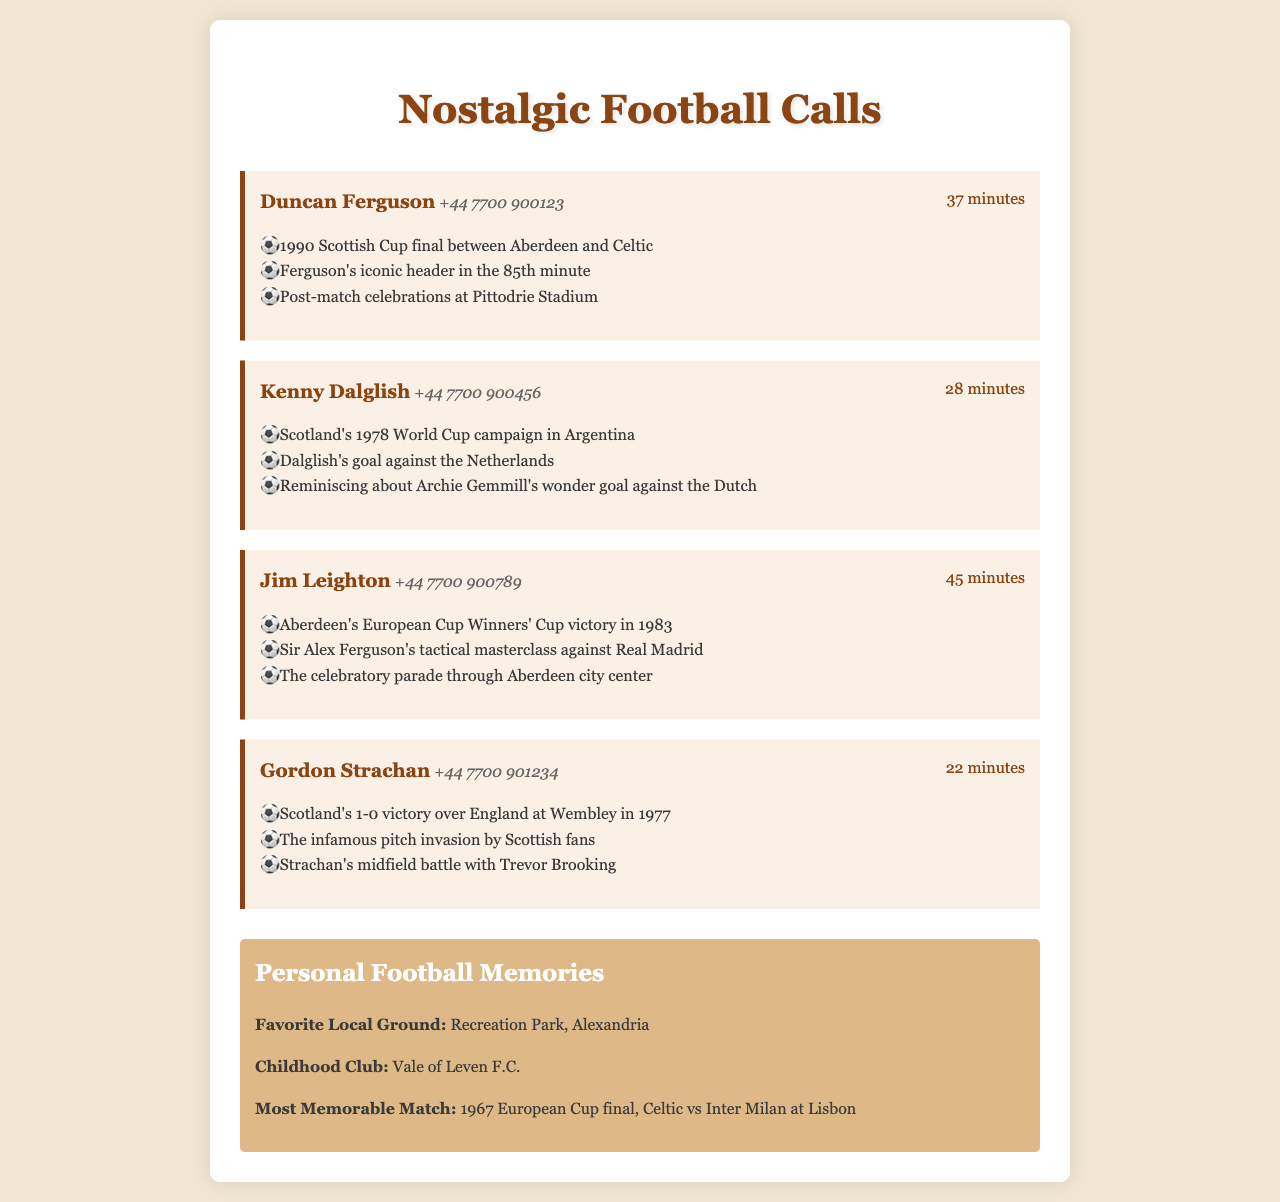What is the name of the first caller? The name of the first caller is provided in the document as Duncan Ferguson.
Answer: Duncan Ferguson How long was the call with Jim Leighton? The duration of the call with Jim Leighton is specified in the document as 45 minutes.
Answer: 45 minutes What significant football event did Gordon Strachan discuss? The document lists Scotland's 1-0 victory over England at Wembley in 1977 as a significant event discussed by Gordon Strachan.
Answer: Scotland's 1-0 victory over England at Wembley in 1977 Who scored an iconic goal mentioned in the call with Kenny Dalglish? The document notes that Dalglish scored a goal during Scotland's World Cup campaign, specifically against the Netherlands.
Answer: Dalglish What was the focus of the call with Duncan Ferguson? The call with Duncan Ferguson focused on the 1990 Scottish Cup final and memorable moments from that match.
Answer: 1990 Scottish Cup final What type of documents does this represent? The content is structured as telephone records detailing long-distance calls.
Answer: Telephone records 